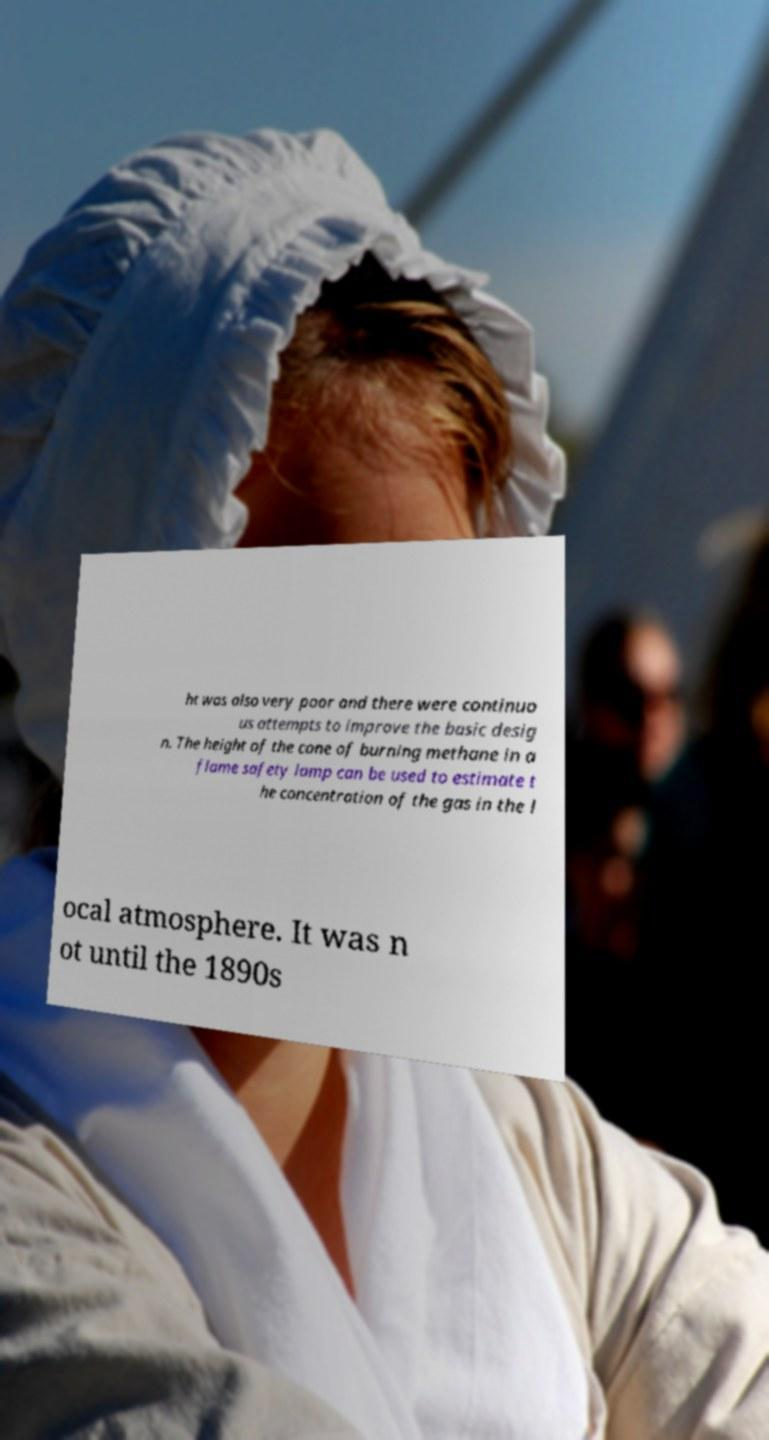Can you accurately transcribe the text from the provided image for me? ht was also very poor and there were continuo us attempts to improve the basic desig n. The height of the cone of burning methane in a flame safety lamp can be used to estimate t he concentration of the gas in the l ocal atmosphere. It was n ot until the 1890s 